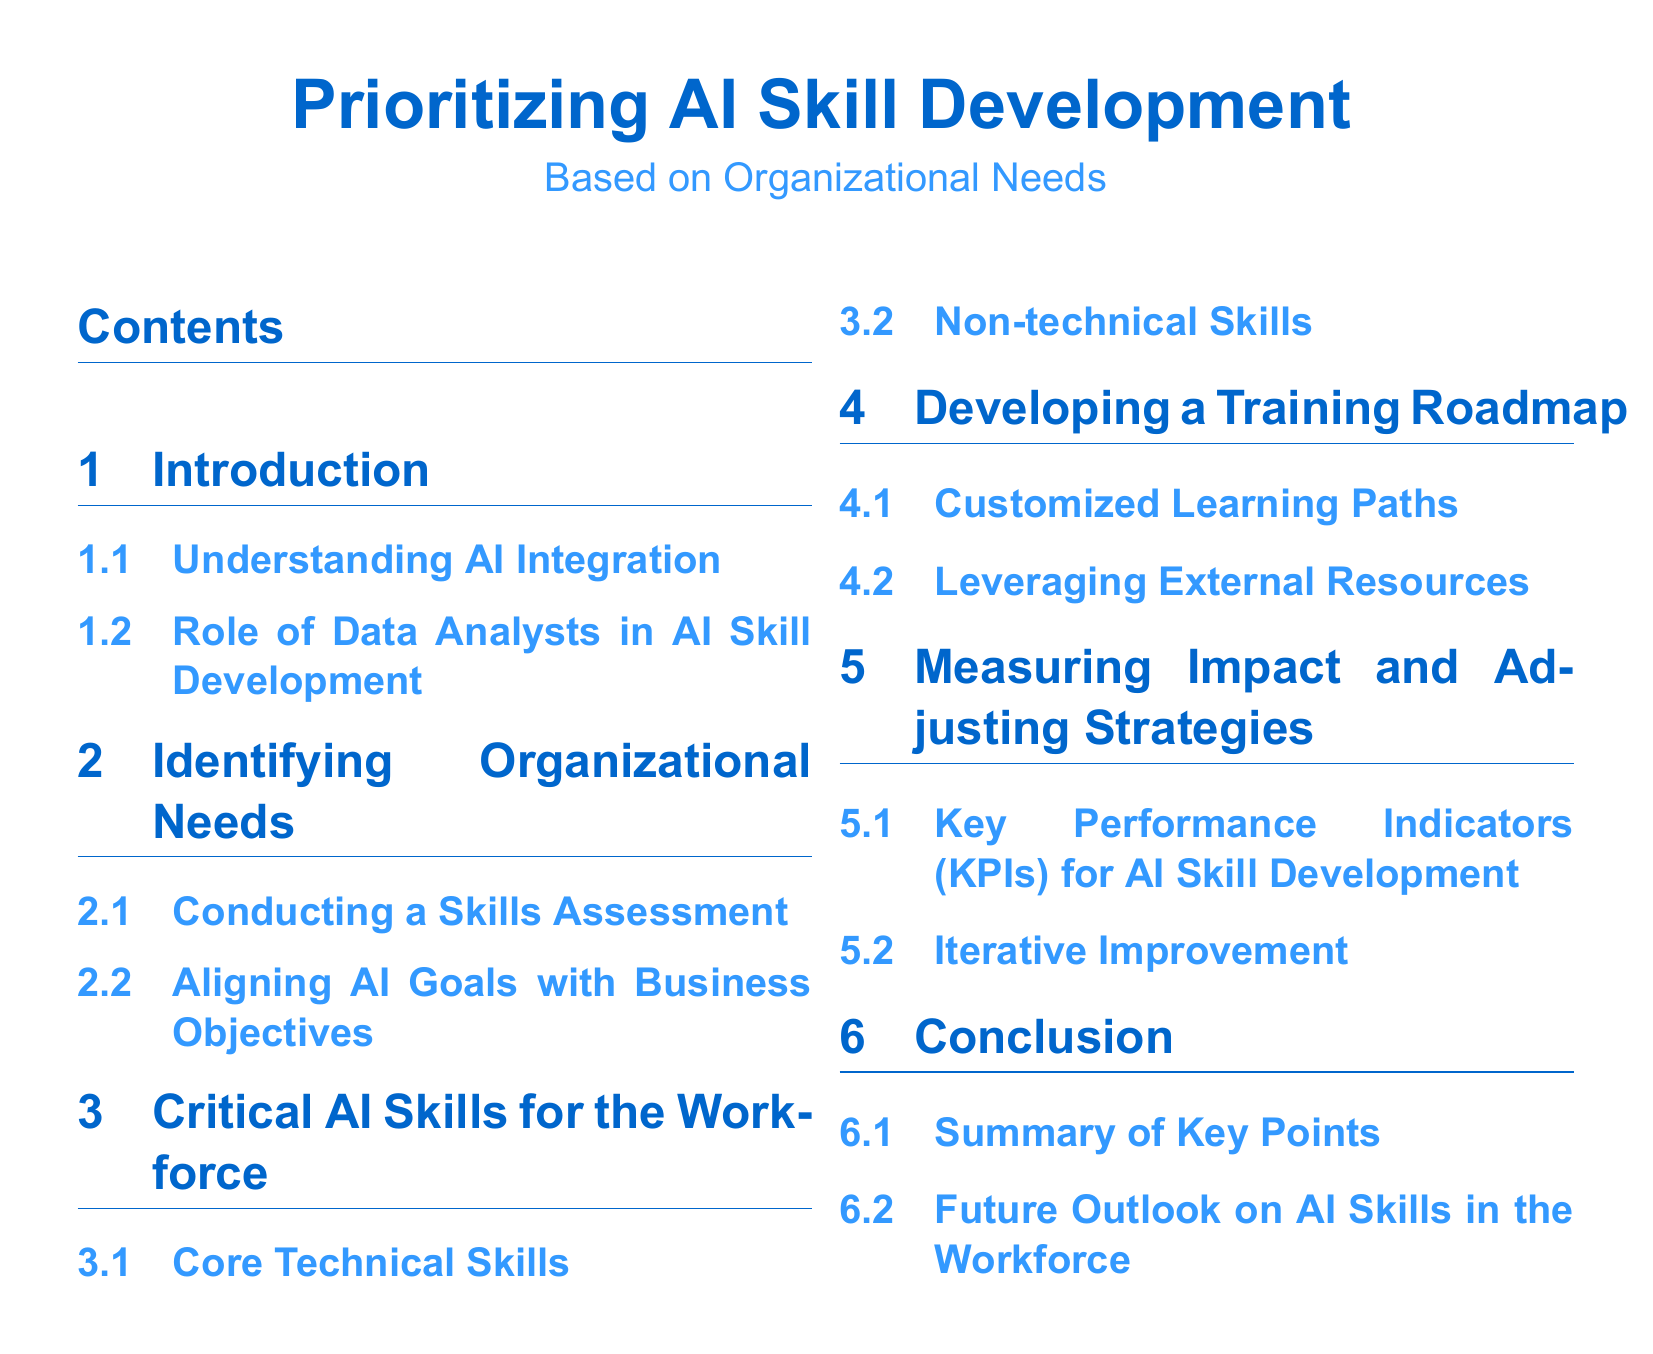What is the main topic of the document? The document focuses on the development of AI skills within organizations based on their specific needs.
Answer: Prioritizing AI Skill Development What section discusses the role of data analysts? The section on the role of data analysts in AI skill development provides insights into their involvement.
Answer: Role of Data Analysts in AI Skill Development Which section contains information about critical AI skills? This section outlines important skills necessary for successful workforce integration of AI.
Answer: Critical AI Skills for the Workforce What is one method mentioned for aligning AI goals with business objectives? The document suggests conducting a skills assessment as a method for alignment.
Answer: Conducting a Skills Assessment What does the section on measuring impact focus on? This section describes how to evaluate the effectiveness of training for AI skill development.
Answer: Key Performance Indicators for AI Skill Development How many subsections are under the section on Developing a Training Roadmap? The document includes two subsections under this section related to training development.
Answer: Two What is the color used for section titles? The title color specified in the document is used to enhance visibility for section headings.
Answer: RGB(0,102,204) What does the conclusion summarize? The conclusion section provides a summary of key points discussed throughout the document.
Answer: Summary of Key Points 